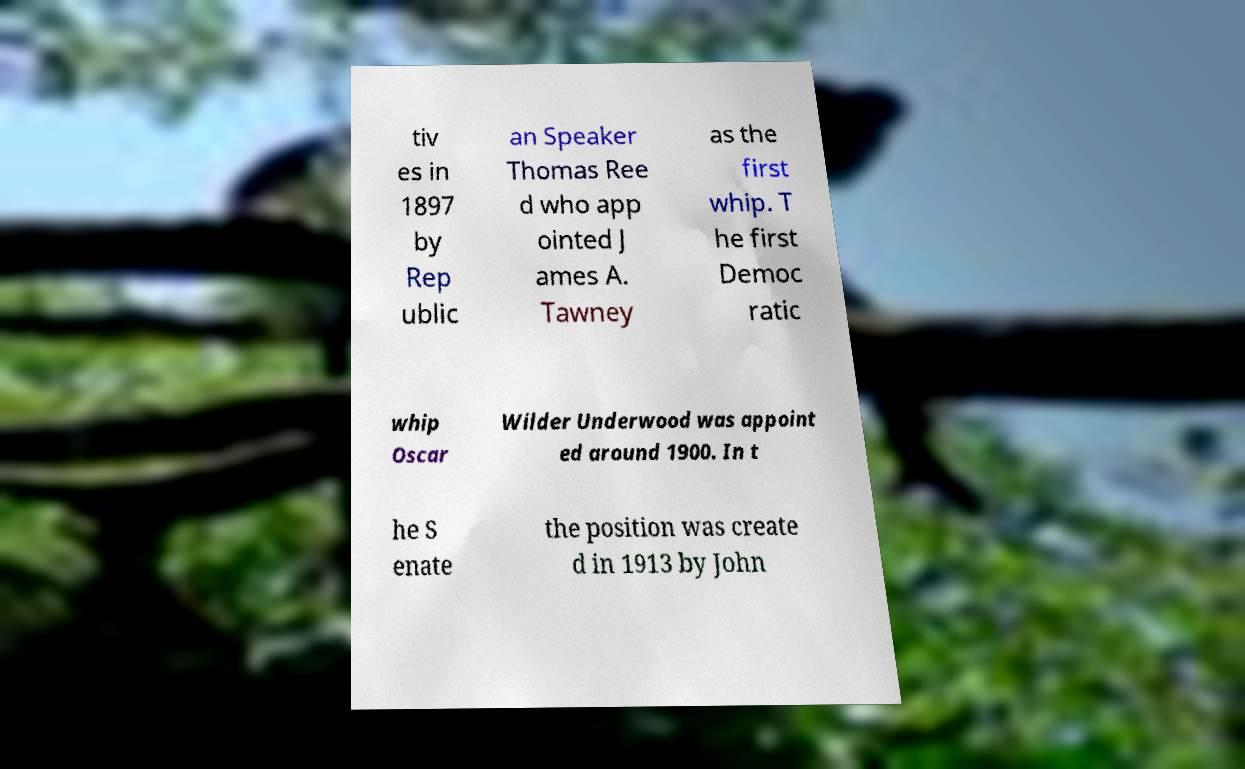There's text embedded in this image that I need extracted. Can you transcribe it verbatim? tiv es in 1897 by Rep ublic an Speaker Thomas Ree d who app ointed J ames A. Tawney as the first whip. T he first Democ ratic whip Oscar Wilder Underwood was appoint ed around 1900. In t he S enate the position was create d in 1913 by John 